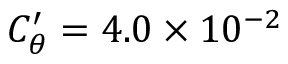<formula> <loc_0><loc_0><loc_500><loc_500>C _ { \theta } ^ { \prime } = 4 . 0 \times 1 0 ^ { - 2 }</formula> 